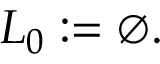<formula> <loc_0><loc_0><loc_500><loc_500>L _ { 0 } \colon = \varnothing .</formula> 